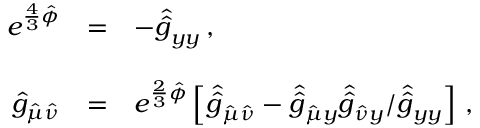<formula> <loc_0><loc_0><loc_500><loc_500>\begin{array} { r c l } { { e ^ { \frac { 4 } { 3 } \hat { \phi } } } } & { = } & { { - \hat { \hat { g } } _ { y y } \, , } } \\ { { \hat { g } _ { \hat { \mu } \hat { \nu } } } } & { = } & { { e ^ { \frac { 2 } { 3 } \hat { \phi } } \left [ \hat { \hat { g } } _ { \hat { \mu } \hat { \nu } } - \hat { \hat { g } } _ { \hat { \mu } y } \hat { \hat { g } } _ { \hat { \nu } y } / \hat { \hat { g } } _ { y y } \right ] \, , } } \end{array}</formula> 